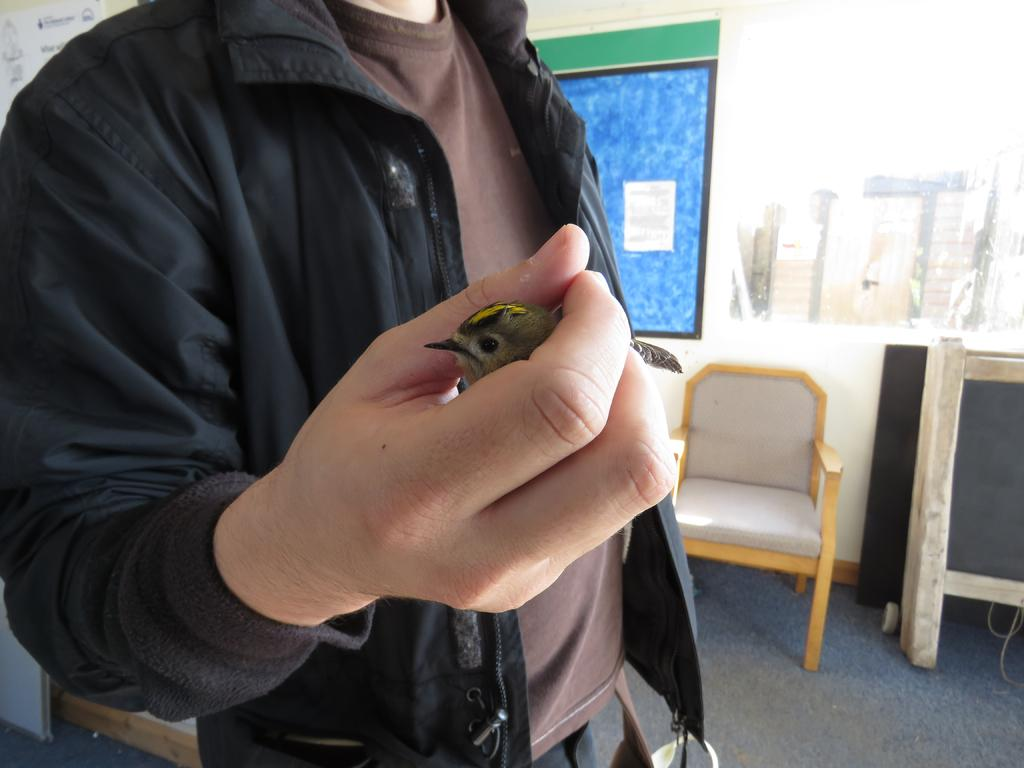What is the person in the image holding? The person is holding a bird in the image. What type of furniture can be seen in the image? There is a chair visible in the image. What type of structure is visible in the image? There is a wall visible in the image. What type of sand can be seen on the scale in the image? There is no sand or scale present in the image. 